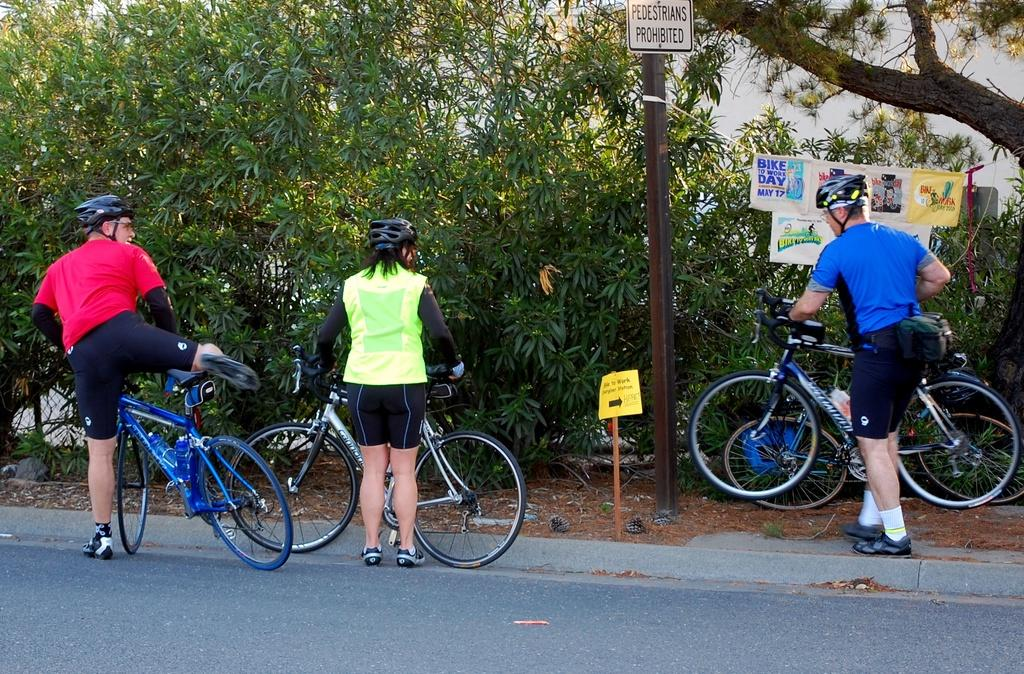What type of vegetation can be seen in the image? There are trees in the image. What object is present in the image that is typically used for displaying information or advertisements? There is a banner in the image. How many people are in the image? There are three people in the image. Where are the people located in the image? The people are standing on the road. What are the people holding in the image? The people are holding bicycles. What type of scarf is the bird wearing in the image? There is no bird or scarf present in the image. What type of bread can be seen in the image? There is no bread present in the image. 